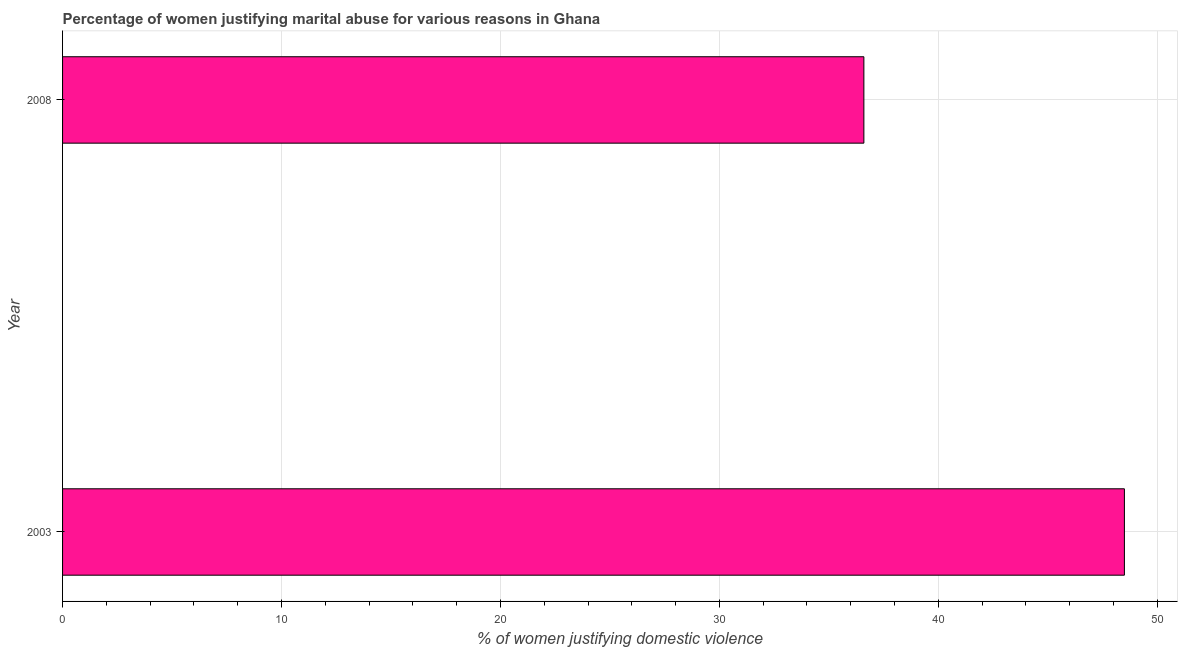Does the graph contain any zero values?
Make the answer very short. No. What is the title of the graph?
Provide a short and direct response. Percentage of women justifying marital abuse for various reasons in Ghana. What is the label or title of the X-axis?
Your response must be concise. % of women justifying domestic violence. What is the percentage of women justifying marital abuse in 2003?
Ensure brevity in your answer.  48.5. Across all years, what is the maximum percentage of women justifying marital abuse?
Your answer should be very brief. 48.5. Across all years, what is the minimum percentage of women justifying marital abuse?
Your answer should be very brief. 36.6. In which year was the percentage of women justifying marital abuse maximum?
Offer a terse response. 2003. In which year was the percentage of women justifying marital abuse minimum?
Give a very brief answer. 2008. What is the sum of the percentage of women justifying marital abuse?
Ensure brevity in your answer.  85.1. What is the difference between the percentage of women justifying marital abuse in 2003 and 2008?
Your answer should be very brief. 11.9. What is the average percentage of women justifying marital abuse per year?
Ensure brevity in your answer.  42.55. What is the median percentage of women justifying marital abuse?
Your answer should be very brief. 42.55. In how many years, is the percentage of women justifying marital abuse greater than 38 %?
Offer a very short reply. 1. Do a majority of the years between 2003 and 2008 (inclusive) have percentage of women justifying marital abuse greater than 34 %?
Provide a succinct answer. Yes. What is the ratio of the percentage of women justifying marital abuse in 2003 to that in 2008?
Your answer should be very brief. 1.32. Are all the bars in the graph horizontal?
Your answer should be very brief. Yes. What is the % of women justifying domestic violence in 2003?
Your answer should be compact. 48.5. What is the % of women justifying domestic violence in 2008?
Make the answer very short. 36.6. What is the difference between the % of women justifying domestic violence in 2003 and 2008?
Your response must be concise. 11.9. What is the ratio of the % of women justifying domestic violence in 2003 to that in 2008?
Offer a very short reply. 1.32. 